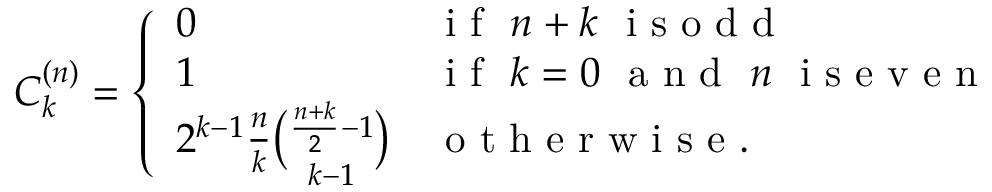Convert formula to latex. <formula><loc_0><loc_0><loc_500><loc_500>C _ { k } ^ { ( n ) } = \left \{ \begin{array} { l l } { 0 } & { i f \ n + k \ i s o d d } \\ { 1 } & { i f \ k = 0 \ a n d \ n \ i s e v e n } \\ { 2 ^ { k - 1 } \frac { n } { k } { \binom { \frac { n + k } { 2 } - 1 } { k - 1 } } } & { o t h e r w i s e . } \end{array}</formula> 